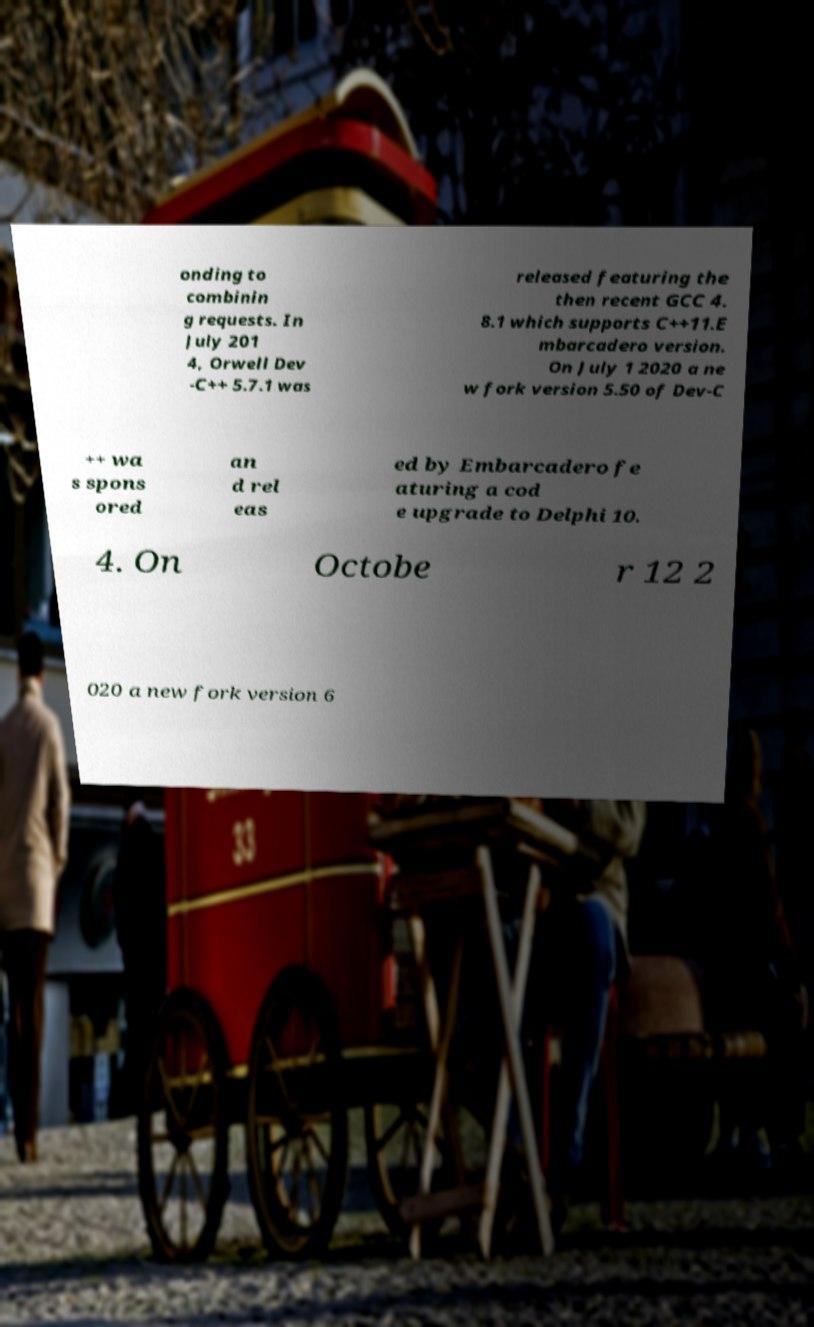What messages or text are displayed in this image? I need them in a readable, typed format. onding to combinin g requests. In July 201 4, Orwell Dev -C++ 5.7.1 was released featuring the then recent GCC 4. 8.1 which supports C++11.E mbarcadero version. On July 1 2020 a ne w fork version 5.50 of Dev-C ++ wa s spons ored an d rel eas ed by Embarcadero fe aturing a cod e upgrade to Delphi 10. 4. On Octobe r 12 2 020 a new fork version 6 